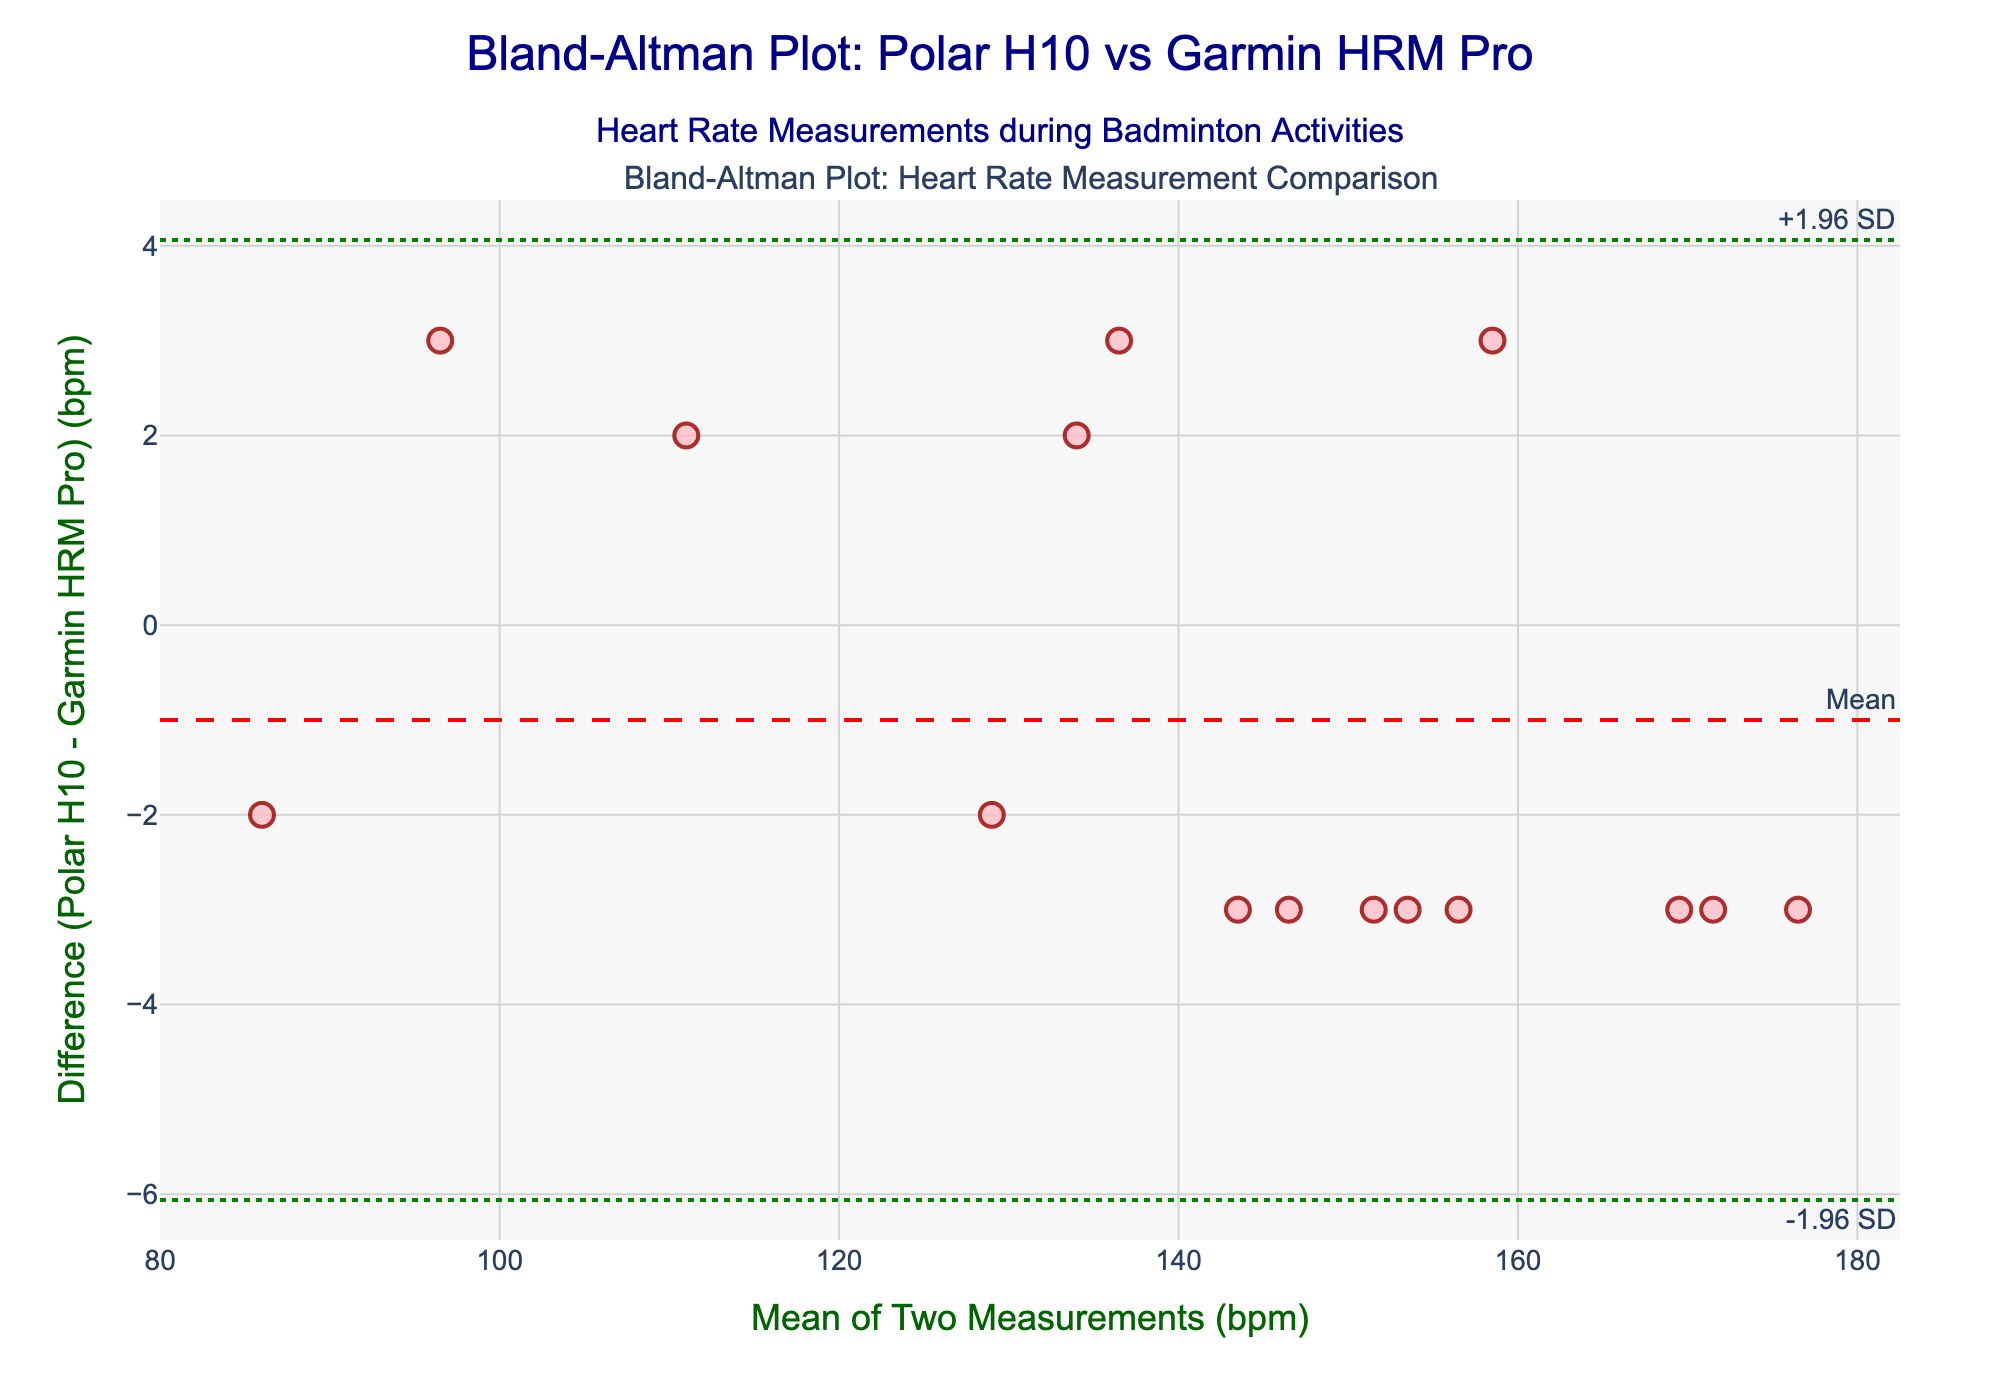How many data points are plotted in the scatter plot? Count the number of markers representing the data points in the scatter plot. There are 15 data points shown for different activities.
Answer: 15 What's the title of the Bland-Altman plot? The plot's title is displayed at the top center of the figure. It reads 'Bland-Altman Plot: Polar H10 vs Garmin HRM Pro' with a subtitle 'Heart Rate Measurements during Badminton Activities'.
Answer: Bland-Altman Plot: Polar H10 vs Garmin HRM Pro What is the mean difference between the two devices' heart rate measurements? The mean difference is indicated by a dashed red horizontal line labeled "Mean." It is the central line in the plot.
Answer: Mean difference: 0 What are the upper and lower limits of agreement? The limits of agreement are shown as dotted green lines labeled "+1.96 SD" and "-1.96 SD" on the plot. These lines represent the range within which most differences between measurements by the two devices fall.
Answer: +1.96 SD: 4.53, -1.96 SD: -4.53 What figure elements indicate the degree of agreement between the two devices' measurements? The degree of agreement is indicated by the mean difference line (red) and the upper and lower limits of agreement (green dotted lines). Most of the points are expected to lie within the limits of agreement for a good agreement.
Answer: Mean difference and limits of agreement Which data point has the highest difference between the two devices? Identify the marker that has the greatest vertical distance from the mean difference line. The data point for "Intense rally" has the highest difference of 3 bpm above the mean.
Answer: Intense rally Are most data points within the limits of agreement? Check whether most of the data points lie within the two green dotted lines representing the limits of agreement. All the data points are within the limits, indicating good agreement.
Answer: Yes What is the difference in heart rate measurements for "Net play"? Locate the marker for "Net play" and note its vertical position relative to the mean difference line. For "Net play," the difference is 155 - 158 = -3 bpm.
Answer: -3 bpm What is the average heart rate measured by the devices across all activities? Calculate the mean heart rate for each activity, then take the average of these means. Add the mean heart rates for each activity and divide by 15. Sum = 85 + 142 + 168 + 155 + 138 + 128 + 112 + 98 + 175 + 150 + 145 + 135 + 170 + 160 + 152 = 2113 bpm. Average = 2113 / 15.
Answer: 140.87 bpm Which activity has the closest mean heart rate measurement to the overall average heart rate? Compare the mean heart rate for each activity to the overall average (140.87 bpm). "Service" has a mean heart rate (142 + 145) / 2 = 143.5 bpm, which is closest to the overall average of 140.87 bpm.
Answer: Service 